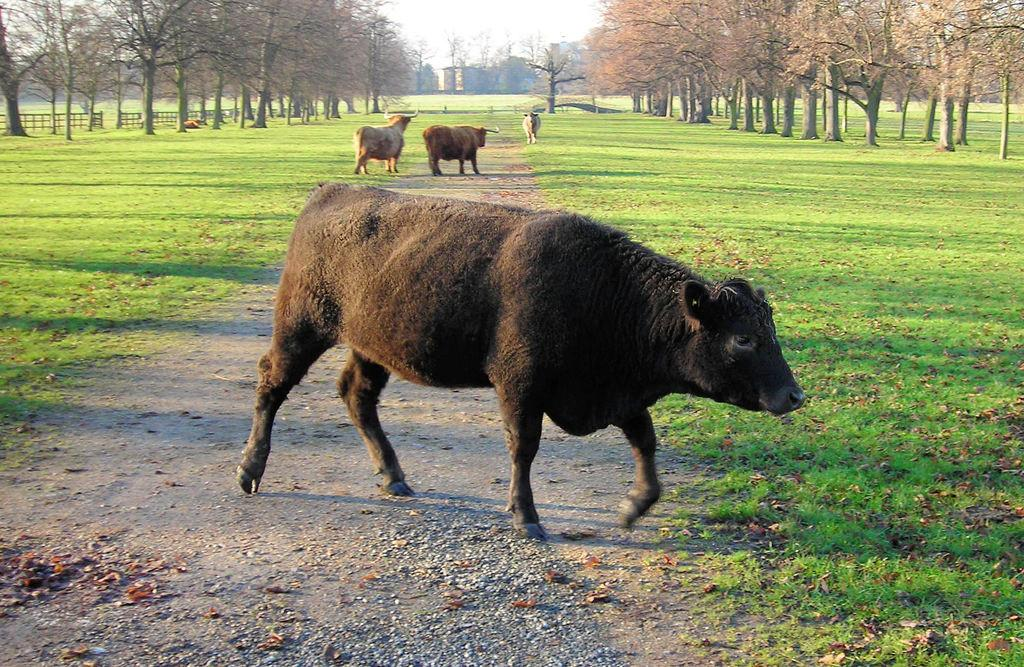What can be seen in the image that people might walk on? There is a path in the image that people might walk on. What animals are walking on the path? Four bulls are walking on the path. What type of vegetation is present on either side of the path? There are trees on either side of the path. What type of ground surface is visible in the image? Grass is present on the ground. Can you see any pockets on the bulls in the image? No, there are no pockets visible on the bulls in the image. 